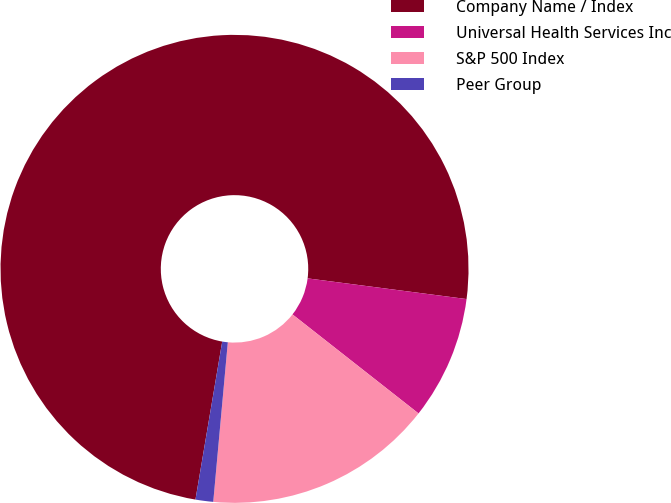<chart> <loc_0><loc_0><loc_500><loc_500><pie_chart><fcel>Company Name / Index<fcel>Universal Health Services Inc<fcel>S&P 500 Index<fcel>Peer Group<nl><fcel>74.39%<fcel>8.54%<fcel>15.85%<fcel>1.22%<nl></chart> 